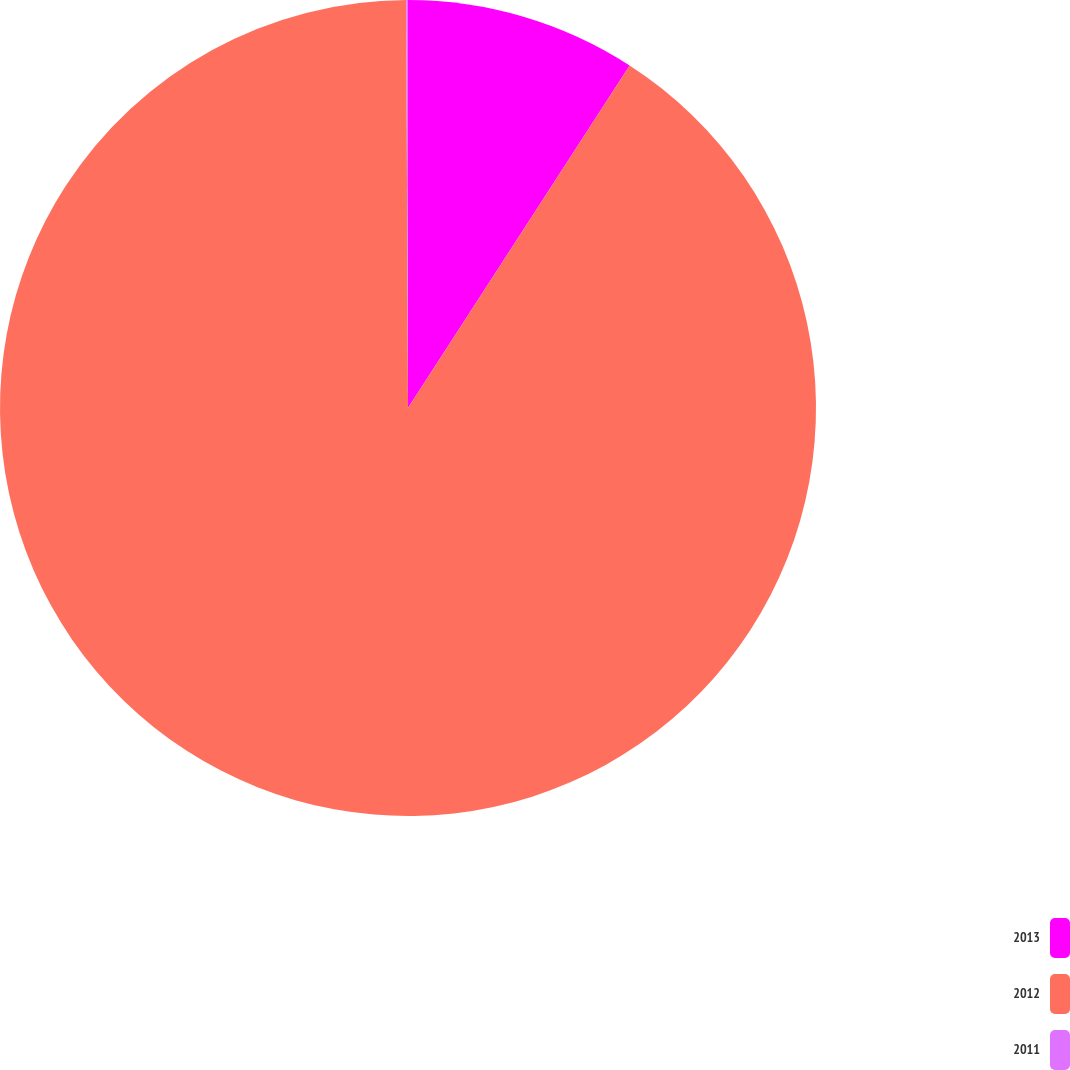Convert chart to OTSL. <chart><loc_0><loc_0><loc_500><loc_500><pie_chart><fcel>2013<fcel>2012<fcel>2011<nl><fcel>9.14%<fcel>90.79%<fcel>0.07%<nl></chart> 